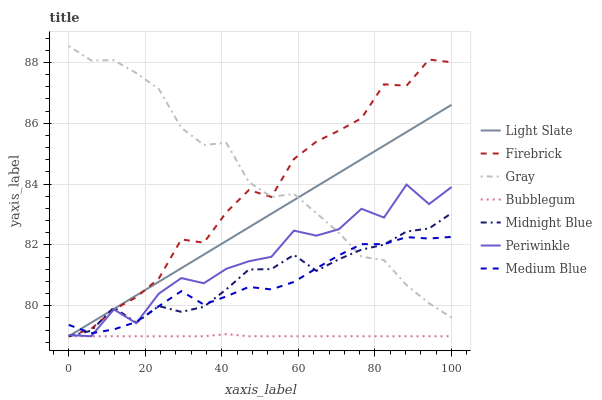Does Bubblegum have the minimum area under the curve?
Answer yes or no. Yes. Does Gray have the maximum area under the curve?
Answer yes or no. Yes. Does Midnight Blue have the minimum area under the curve?
Answer yes or no. No. Does Midnight Blue have the maximum area under the curve?
Answer yes or no. No. Is Light Slate the smoothest?
Answer yes or no. Yes. Is Periwinkle the roughest?
Answer yes or no. Yes. Is Midnight Blue the smoothest?
Answer yes or no. No. Is Midnight Blue the roughest?
Answer yes or no. No. Does Midnight Blue have the lowest value?
Answer yes or no. Yes. Does Medium Blue have the lowest value?
Answer yes or no. No. Does Gray have the highest value?
Answer yes or no. Yes. Does Midnight Blue have the highest value?
Answer yes or no. No. Is Bubblegum less than Gray?
Answer yes or no. Yes. Is Gray greater than Bubblegum?
Answer yes or no. Yes. Does Firebrick intersect Light Slate?
Answer yes or no. Yes. Is Firebrick less than Light Slate?
Answer yes or no. No. Is Firebrick greater than Light Slate?
Answer yes or no. No. Does Bubblegum intersect Gray?
Answer yes or no. No. 